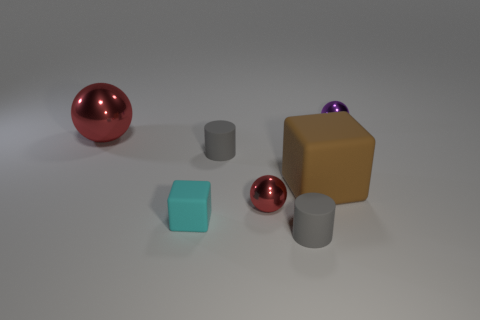Add 3 small gray rubber cylinders. How many objects exist? 10 Subtract all red shiny spheres. How many spheres are left? 1 Subtract all purple spheres. How many spheres are left? 2 Subtract 2 cubes. How many cubes are left? 0 Subtract 0 blue cubes. How many objects are left? 7 Subtract all spheres. How many objects are left? 4 Subtract all red cylinders. Subtract all green spheres. How many cylinders are left? 2 Subtract all brown cubes. How many purple balls are left? 1 Subtract all red matte cubes. Subtract all gray matte cylinders. How many objects are left? 5 Add 7 tiny red metallic objects. How many tiny red metallic objects are left? 8 